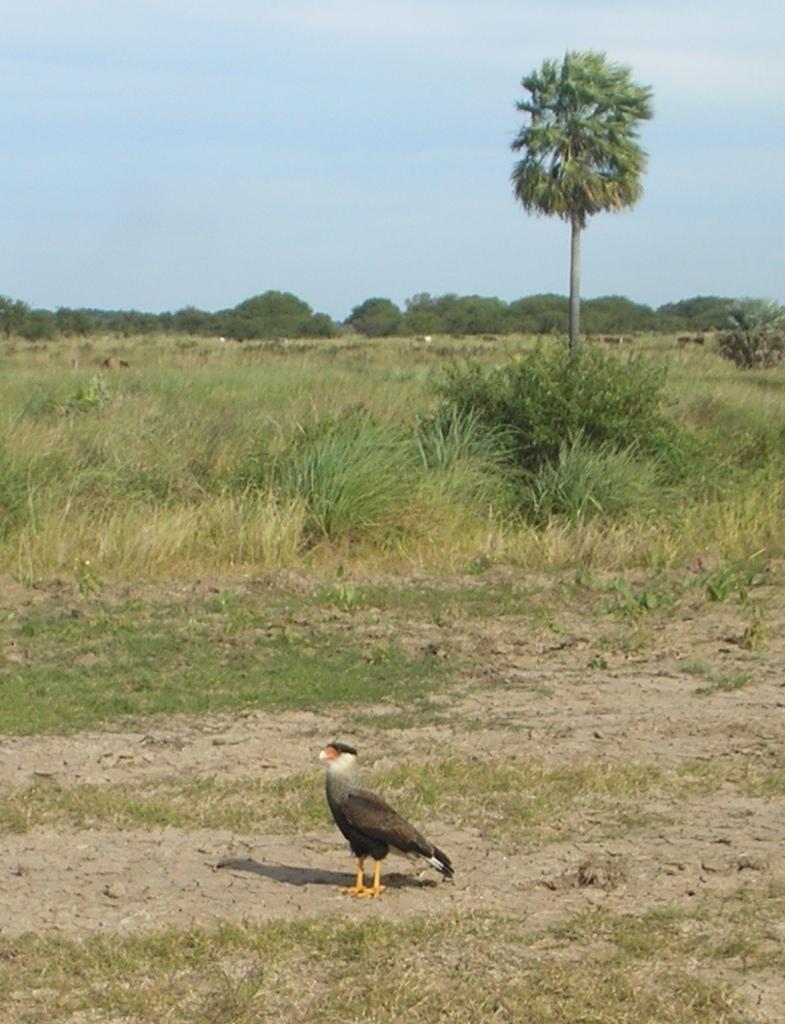Can you describe this image briefly? In the center of the image we can see a bird. In the background there is grass, trees and sky. 